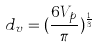Convert formula to latex. <formula><loc_0><loc_0><loc_500><loc_500>d _ { v } = ( \frac { 6 V _ { p } } { \pi } ) ^ { \frac { 1 } { 3 } }</formula> 